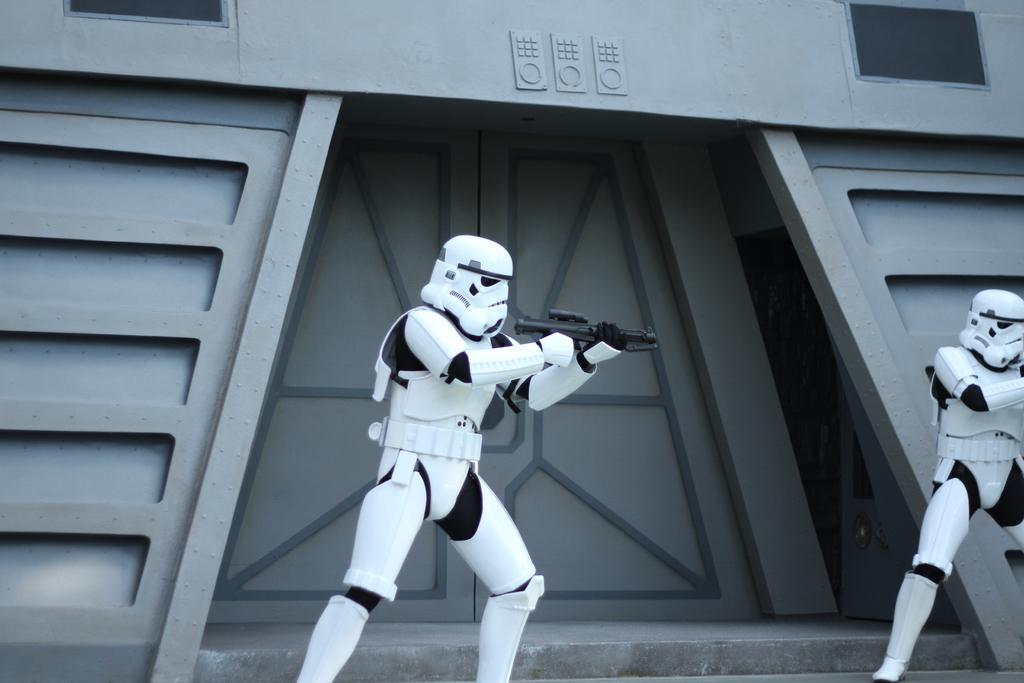Describe this image in one or two sentences. In the image there two robots holding guns and behind them there is a building with a entrance in the middle. 